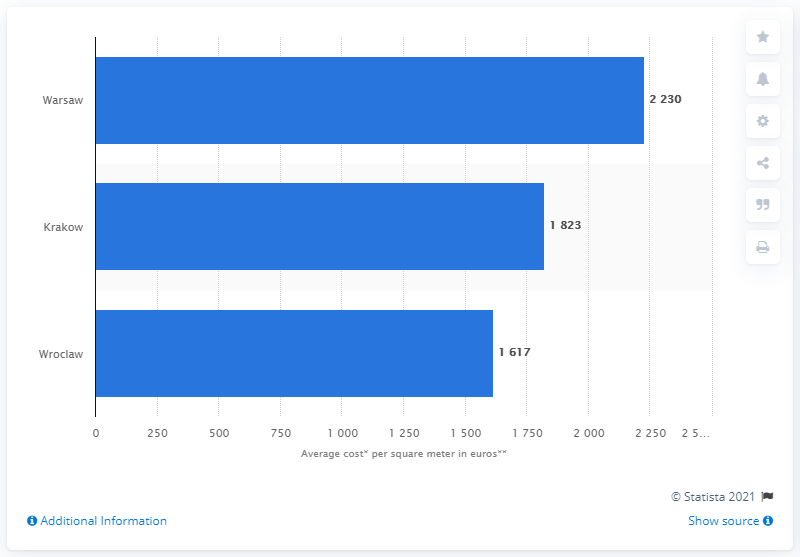Outline some significant characteristics in this image. Warsaw was the most expensive city in which to purchase an apartment. 